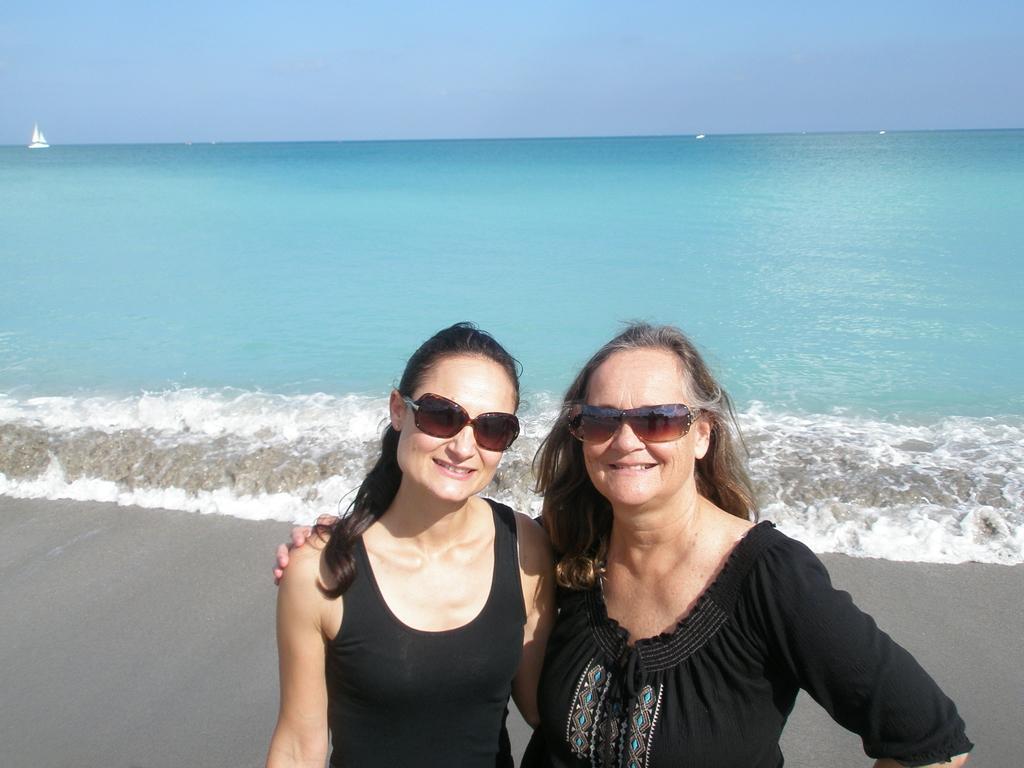How would you summarize this image in a sentence or two? In this picture there is a woman who is wearing goggles and black dress. Beside her we can see young lady who is wearing goggles and black dress. Both of them are standing on the beach. In the background we can see ocean. On the left there is a boat. On the top we can sea sky and clouds. 